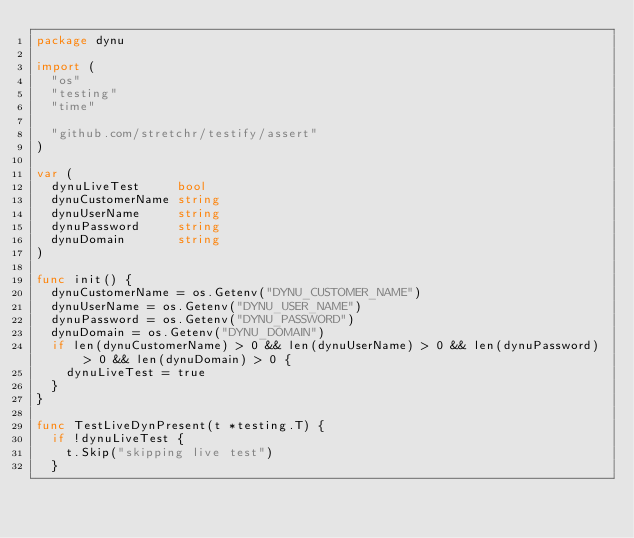<code> <loc_0><loc_0><loc_500><loc_500><_Go_>package dynu

import (
	"os"
	"testing"
	"time"

	"github.com/stretchr/testify/assert"
)

var (
	dynuLiveTest     bool
	dynuCustomerName string
	dynuUserName     string
	dynuPassword     string
	dynuDomain       string
)

func init() {
	dynuCustomerName = os.Getenv("DYNU_CUSTOMER_NAME")
	dynuUserName = os.Getenv("DYNU_USER_NAME")
	dynuPassword = os.Getenv("DYNU_PASSWORD")
	dynuDomain = os.Getenv("DYNU_DOMAIN")
	if len(dynuCustomerName) > 0 && len(dynuUserName) > 0 && len(dynuPassword) > 0 && len(dynuDomain) > 0 {
		dynuLiveTest = true
	}
}

func TestLiveDynPresent(t *testing.T) {
	if !dynuLiveTest {
		t.Skip("skipping live test")
	}
</code> 